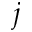<formula> <loc_0><loc_0><loc_500><loc_500>j</formula> 